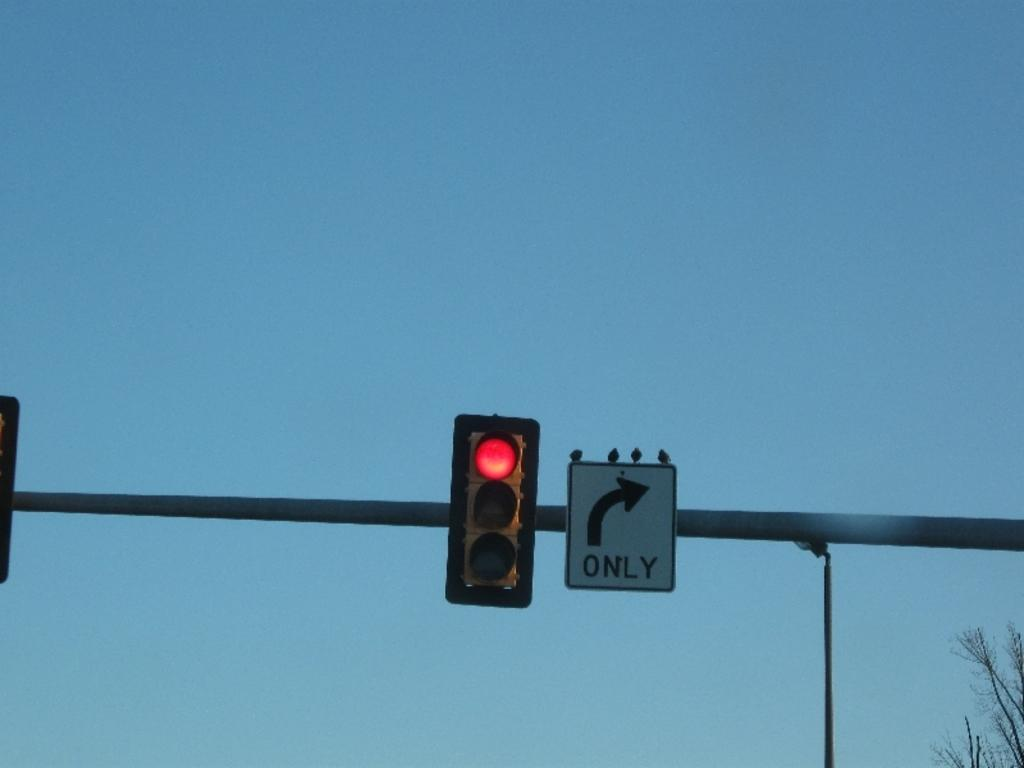<image>
Describe the image concisely. a red light and a sign indicating right turns only. 